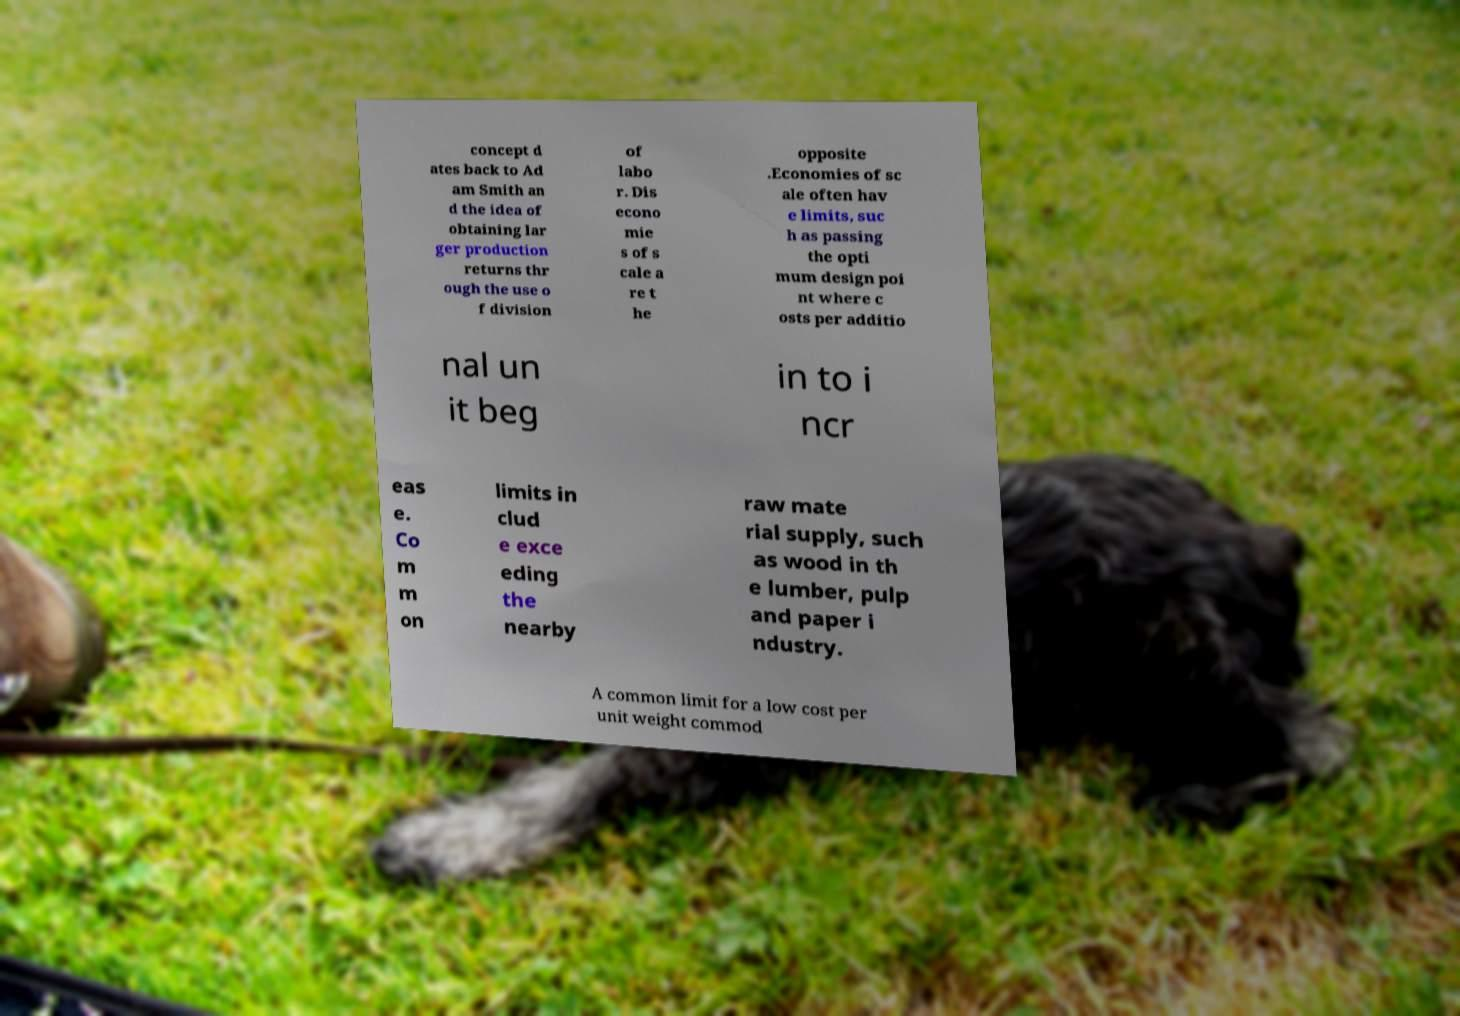Please read and relay the text visible in this image. What does it say? concept d ates back to Ad am Smith an d the idea of obtaining lar ger production returns thr ough the use o f division of labo r. Dis econo mie s of s cale a re t he opposite .Economies of sc ale often hav e limits, suc h as passing the opti mum design poi nt where c osts per additio nal un it beg in to i ncr eas e. Co m m on limits in clud e exce eding the nearby raw mate rial supply, such as wood in th e lumber, pulp and paper i ndustry. A common limit for a low cost per unit weight commod 